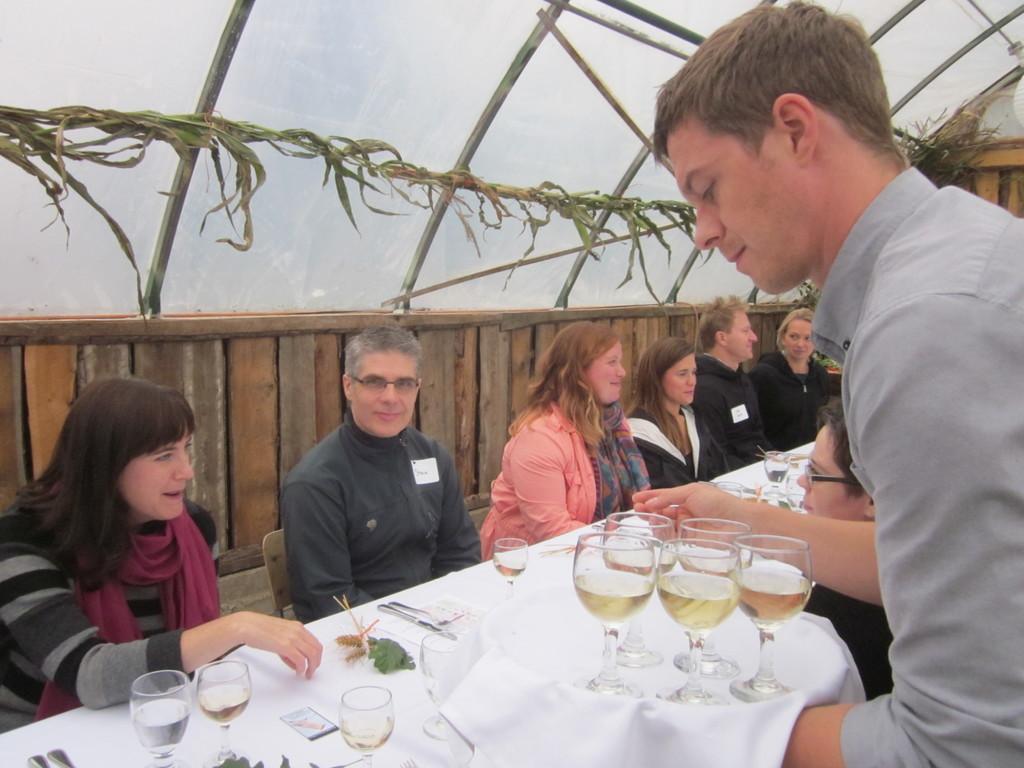Can you describe this image briefly? This persons are sitting on a chair. On this table there are glasses and spoons. This person is standing and holding a tray. On this tree there are glasses. 